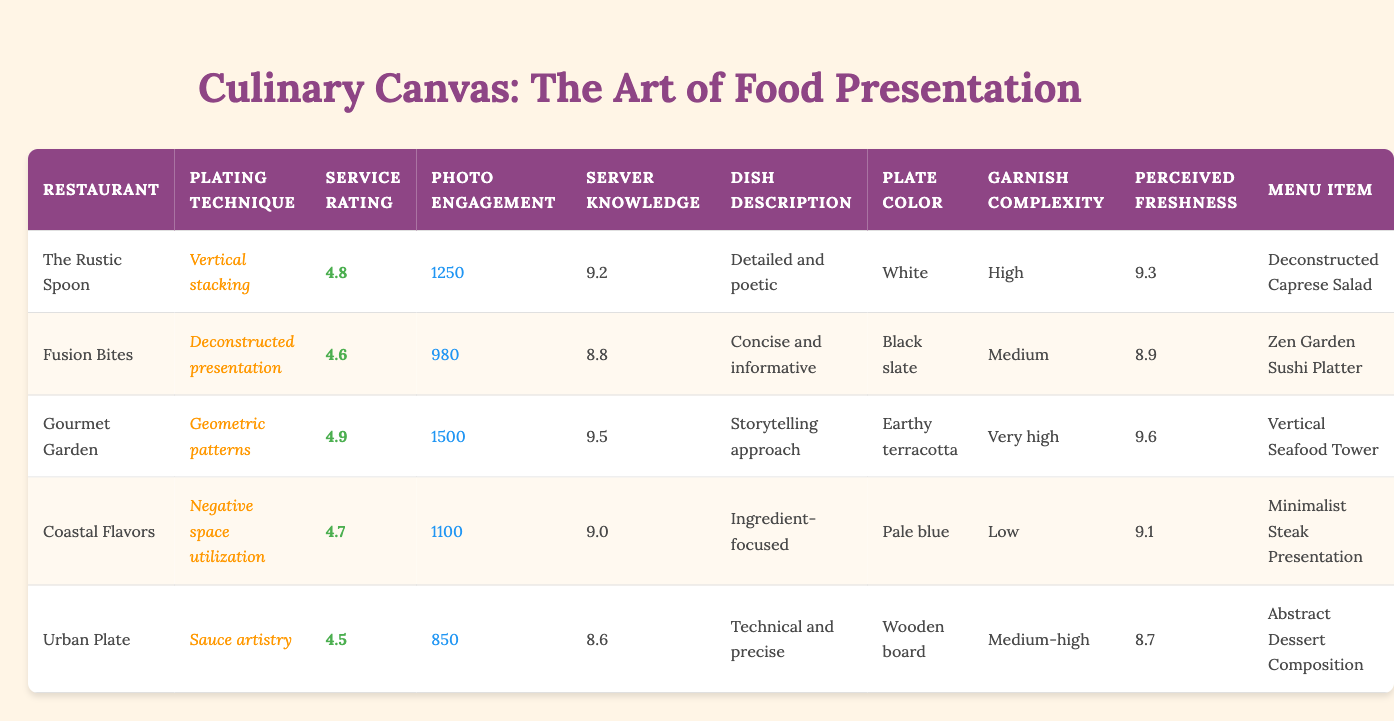What is the service rating for Gourmet Garden? The service rating for Gourmet Garden is found directly in the table. According to the data, it is listed next to the restaurant name Gourmet Garden.
Answer: 4.9 Which restaurant uses 'Negative space utilization' as its plating technique? By scanning the table for the plating techniques, Negative space utilization corresponds to Coastal Flavors, as it appears in the same row as that restaurant's name.
Answer: Coastal Flavors What is the average perceived freshness across all dishes? To find the average perceived freshness, we add all the values: (9.3 + 8.9 + 9.6 + 9.1 + 8.7) = 45.6 and divide by the number of dishes, which is 5. So, the average is 45.6 / 5 = 9.12.
Answer: 9.12 Which plating technique has the highest service rating? We can compare the service ratings across the techniques by identifying and comparing the values in the service rating column. Gourmet Garden has the highest rating at 4.9, linked to the Geometric patterns technique.
Answer: Geometric patterns Is there any restaurant with a server knowledge score below 9.0? By reviewing the server knowledge score column, we find that Urban Plate is the only restaurant with a score below 9.0, as its score is 8.6.
Answer: Yes How does the food photo engagement for the restaurant with the highest perceived freshness compare to the average engagement? The restaurant with the highest perceived freshness is Gourmet Garden with a score of 9.6 and has a food photo engagement of 1500. The average engagement sums to (1250 + 980 + 1500 + 1100 + 850) = 4680 and dividing by 5 gives an average of 936. Comparing these, 1500 is significantly higher than 936.
Answer: Higher What dish from Urban Plate is described as 'Technical and precise'? The dish description quality for Urban Plate lists 'Technical and precise' directly next to its restaurant name. The corresponding menu item is Abstract Dessert Composition.
Answer: Abstract Dessert Composition Which restaurant has the lowest garnish complexity and what is it? Scanning the garnish complexity column, we see that Coastal Flavors has the lowest complexity level listed as 'Low.'
Answer: Coastal Flavors, Low How does Fusion Bites' serving rating rank relative to the average service rating of all restaurants? Fusion Bites has a service rating of 4.6. The average service rating across all restaurants is (4.8 + 4.6 + 4.9 + 4.7 + 4.5) = 24.5, divided by 5 gives 4.9. Comparing 4.6 to 4.9 shows it is slightly below the average.
Answer: Below average What correlation can be observed between plate color and plating technique among these restaurants? By analyzing the plate color, it can be observed that different techniques are paired with distinct colors but there isn’t a direct correlation noted in the data. Examples include white plates for vertical stacking and black slate for deconstructed presentation.
Answer: No clear correlation 